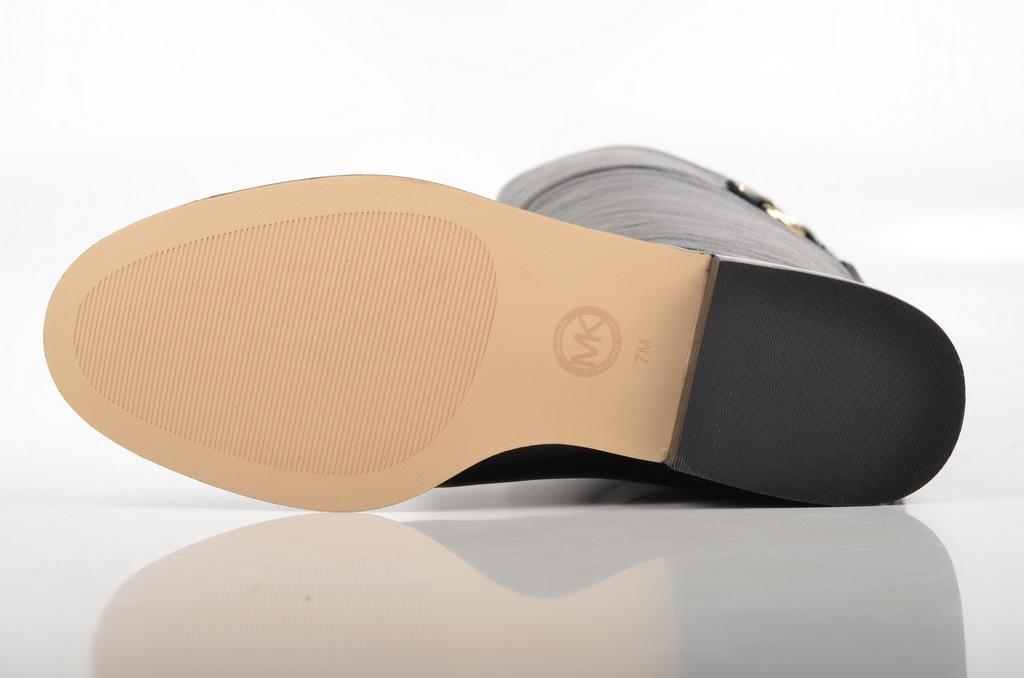What is the main subject of the image? The main subject of the image is the sole of a shoe. What is the color of the background in the image? The background of the image is white. Is there a hook hanging from the sole of the shoe in the image? No, there is no hook present in the image. What level of the shelf is the shoe placed on in the image? There is no shelf present in the image; it only features the sole of a shoe on a white background. 